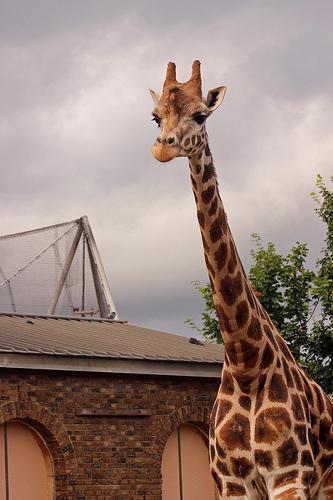How many arches?
Give a very brief answer. 2. 